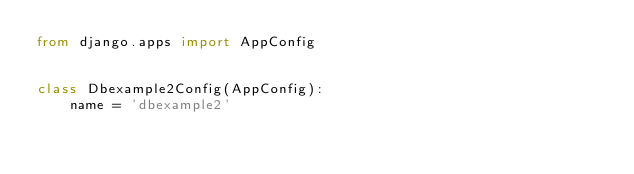<code> <loc_0><loc_0><loc_500><loc_500><_Python_>from django.apps import AppConfig


class Dbexample2Config(AppConfig):
    name = 'dbexample2'
</code> 